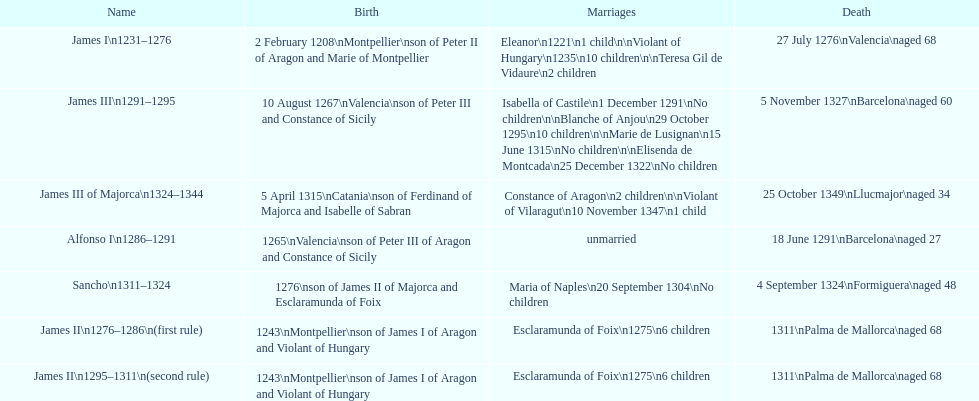At what age did both james i and james ii meet their demise? 68. 